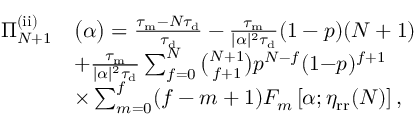Convert formula to latex. <formula><loc_0><loc_0><loc_500><loc_500>\begin{array} { r l } { \Pi _ { N + 1 } ^ { ( i i ) } } & { \left ( \alpha \right ) = \frac { \tau _ { m } - N \tau _ { d } } { \tau _ { d } } - \frac { \tau _ { m } } { | \alpha | ^ { 2 } \tau _ { d } } ( 1 - p ) ( N + 1 ) } \\ & { + \frac { \tau _ { m } } { | \alpha | ^ { 2 } \tau _ { d } } \sum _ { f = 0 } ^ { N } \binom { N + 1 } { f + 1 } p ^ { N - f } ( 1 { - } p ) ^ { f + 1 } } \\ & { \times \sum _ { m = 0 } ^ { f } ( f - m + 1 ) F _ { m } \left [ \alpha ; \eta _ { r r } ( N ) \right ] , } \end{array}</formula> 